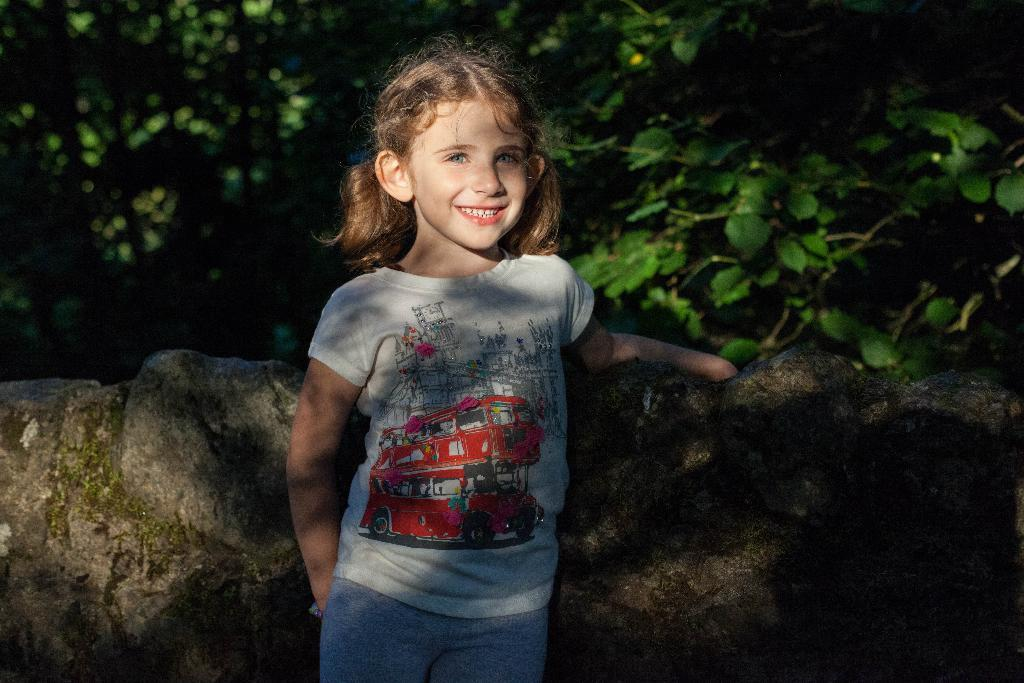Who is the main subject in the image? There is a girl in the image. What is the girl doing in the image? The girl is standing in front of a stone wall and smiling. What can be seen behind the girl in the image? There are many trees visible behind the girl. What type of punishment is the girl receiving in the image? There is no indication of punishment in the image; the girl is smiling and standing in front of a stone wall. Can you see the seashore in the image? No, the image does not show the seashore; it features a girl standing in front of a stone wall with trees visible behind her. 